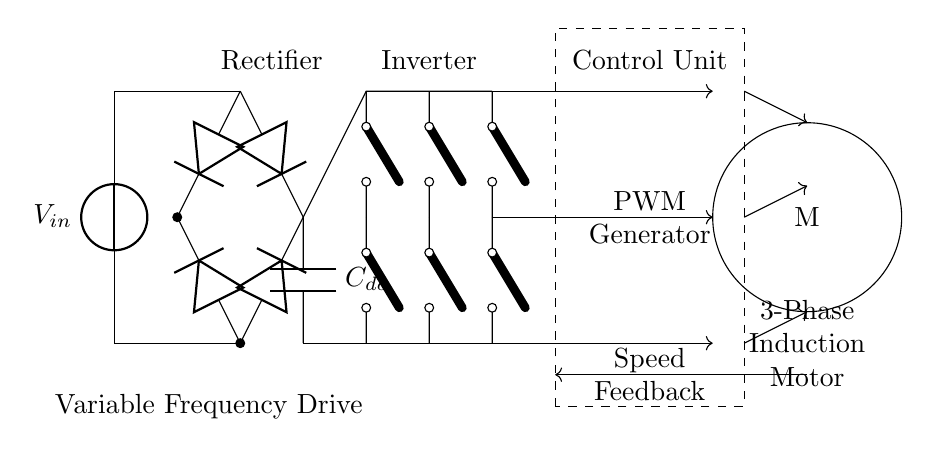What is the input voltage represented in the circuit? The input voltage is labeled as V in, indicating it is the source voltage for the circuit.
Answer: V in What does the capacitor C dc represent in the circuit? The capacitor C dc acts as a smoothing component in the DC link, storing electrical energy and reducing ripple voltage after rectification.
Answer: Smoothing component What is the main function of the inverter in this circuit? The inverter converts the DC voltage from the DC link into AC voltage suitable for driving the induction motor, allowing for speed control through variable frequency.
Answer: Convert DC to AC How many diodes are used in the rectifier? There are four diodes in the rectifier section, as indicated by the connections and symbols shown in the diagram.
Answer: Four What is the role of the PWM generator in the control unit? The PWM generator produces pulse-width modulation signals to control the inverter's output voltage and frequency, indirectly regulating the speed of the induction motor.
Answer: Control output voltage and frequency How is feedback incorporated into this circuit? Feedback is provided through the speed feedback line coming from the motor, which is fed back into the control unit for real-time speed regulation.
Answer: Real-time speed regulation What type of motor is used in this circuit? The motor used is a 3-phase induction motor, as indicated in the labeling on the diagram.
Answer: 3-phase induction motor 